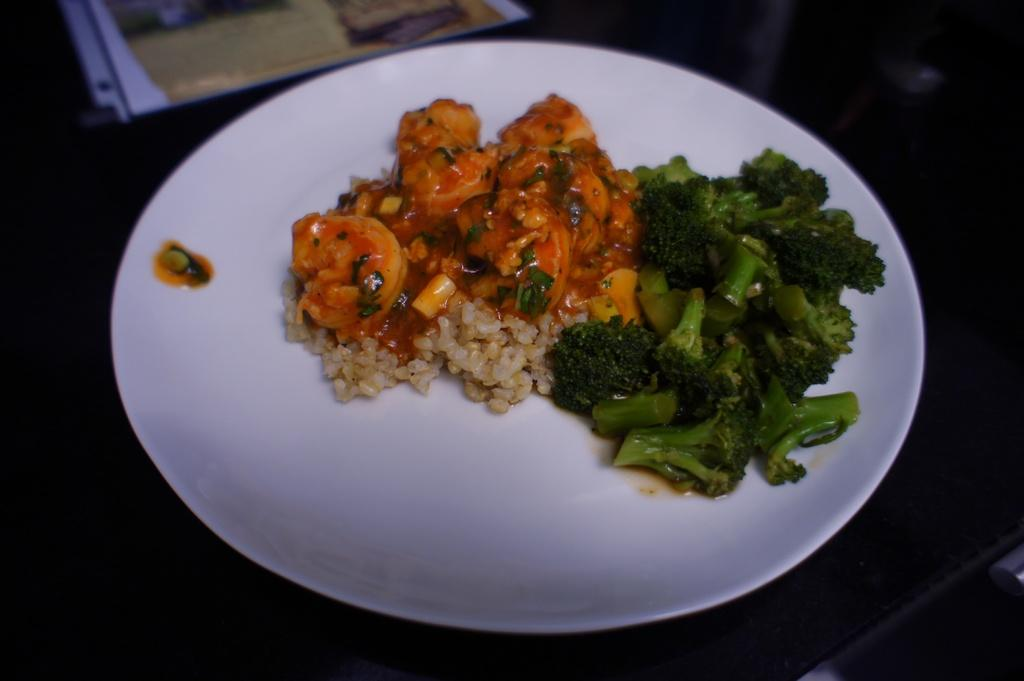What type of vegetable can be seen in the image? There are broccoli pieces in the image. What else can be found in the image besides the broccoli? There are other food items in the image. What color is the plate that holds the food items? The plate is white in color. What type of pancake is causing the broccoli to move in the image? There is no pancake present in the image, and the broccoli is not moving. 